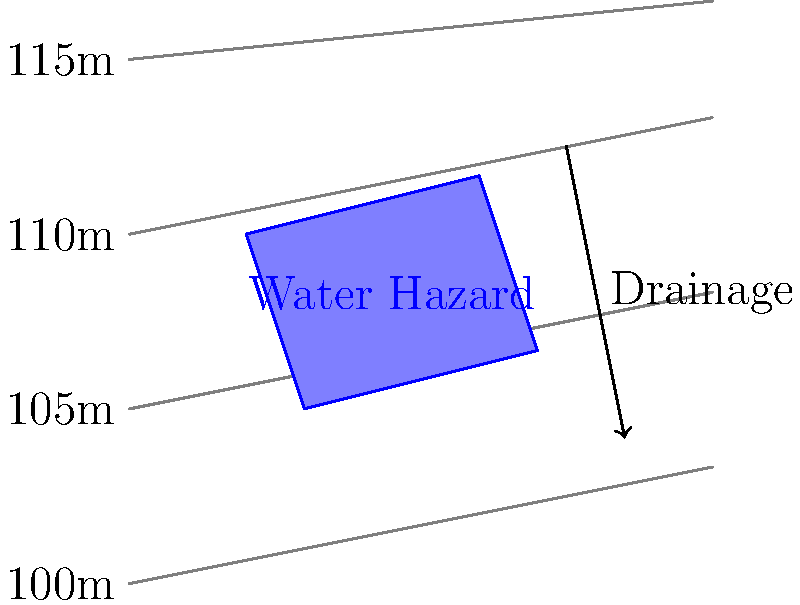A new water hazard is being designed for a golf course. The contour map above shows the proposed location of the water hazard and the surrounding terrain. The contour lines are spaced at 5-meter intervals, starting from 100 meters above sea level at the bottom. 

Calculate the average slope (as a percentage) of the terrain in the direction of the drainage arrow, assuming the arrow spans a horizontal distance of 50 meters. To calculate the average slope, we need to determine the change in elevation over the horizontal distance. Let's approach this step-by-step:

1. Identify the elevations at the start and end of the drainage arrow:
   - Start point (approximate): between 110m and 115m contour lines, closer to 115m. Estimate 114m.
   - End point: between 100m and 105m contour lines, closer to 105m. Estimate 103m.

2. Calculate the change in elevation:
   $\Delta \text{elevation} = 114\text{m} - 103\text{m} = 11\text{m}$

3. Given horizontal distance: 50 meters

4. Calculate the slope as a percentage:
   Slope (%) = $\frac{\text{Change in elevation}}{\text{Horizontal distance}} \times 100\%$
   
   Slope (%) = $\frac{11\text{m}}{50\text{m}} \times 100\% = 0.22 \times 100\% = 22\%$

Therefore, the average slope in the direction of the drainage arrow is approximately 22%.
Answer: 22% 